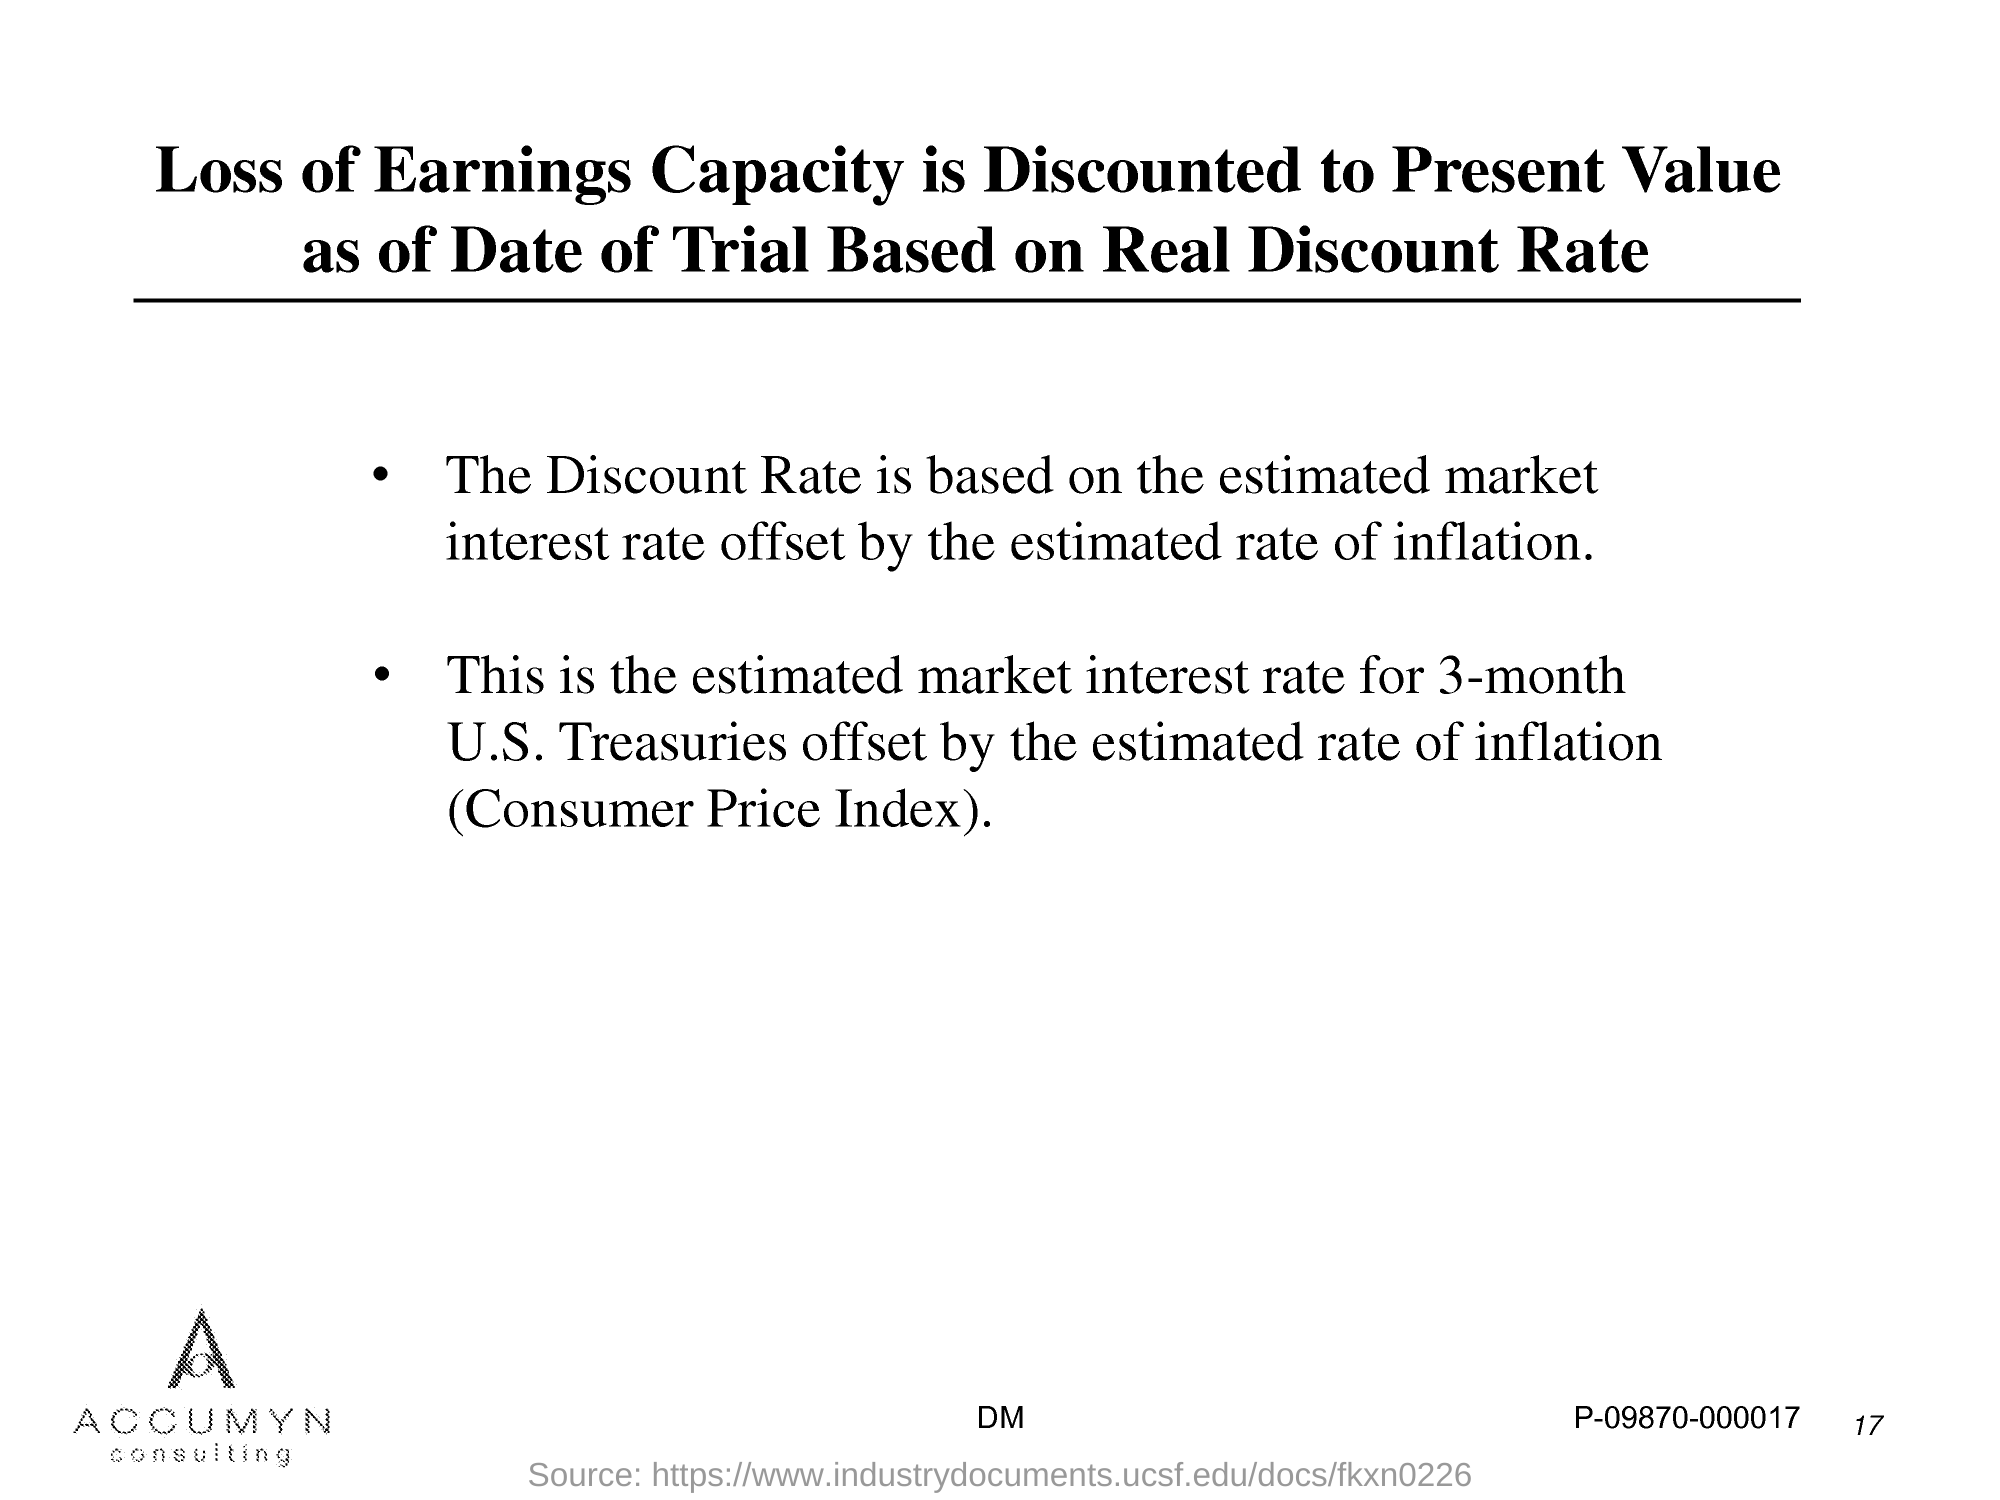What is the Page Number?
Provide a succinct answer. 17. 